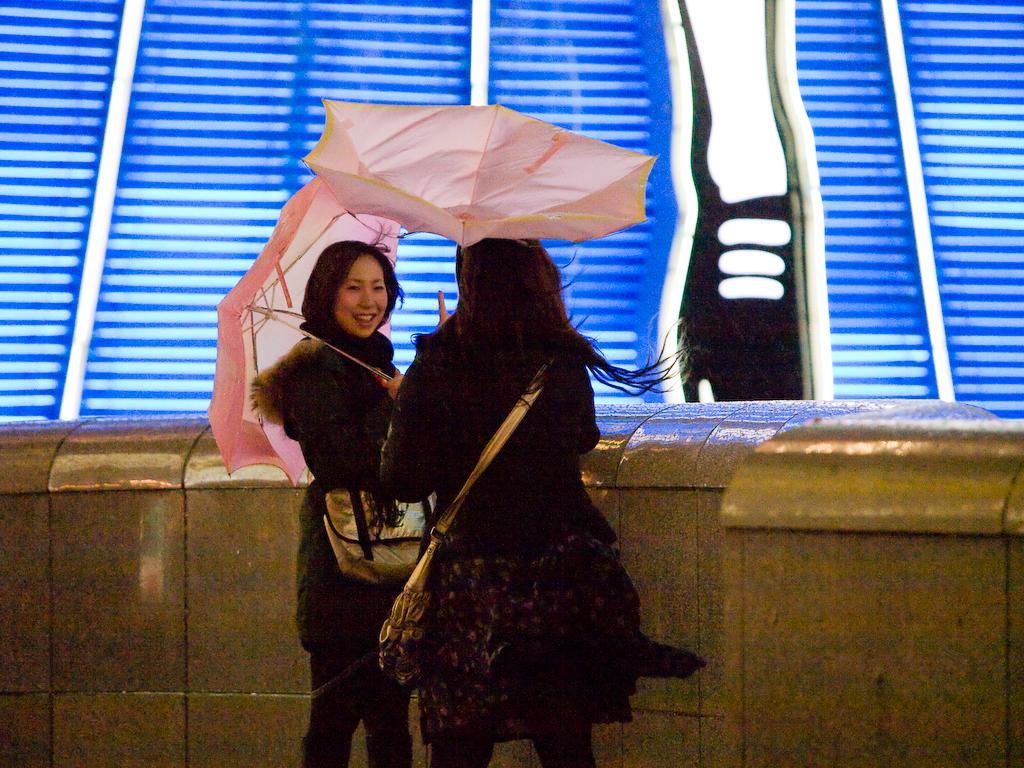How would you summarize this image in a sentence or two? There are two ladies wearing bags. They are holding umbrellas. Near to them there is a wall. In the back there is a wall with blue and white color. 